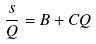Convert formula to latex. <formula><loc_0><loc_0><loc_500><loc_500>\frac { s } { Q } = B + C Q</formula> 